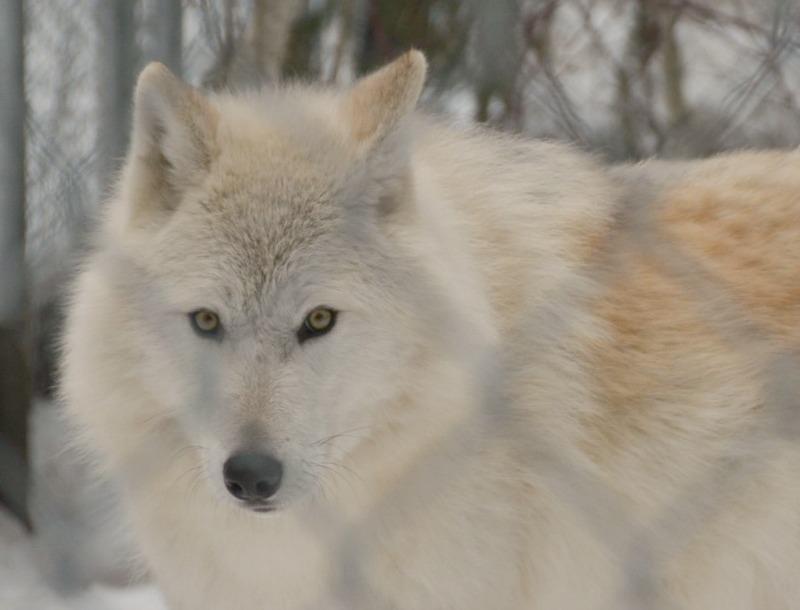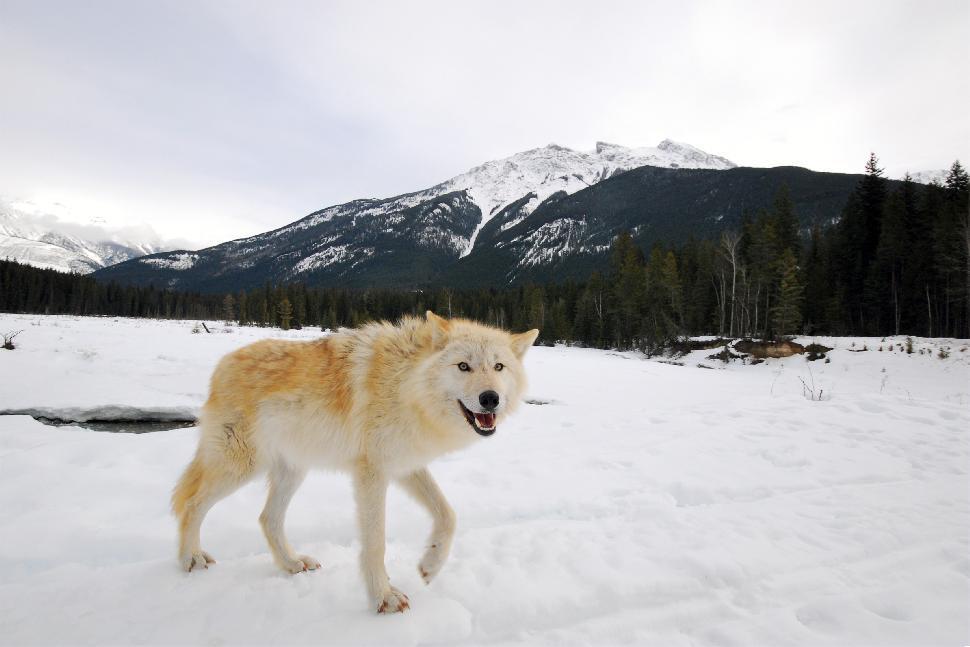The first image is the image on the left, the second image is the image on the right. Considering the images on both sides, is "At least one of the wild dogs is laying down and none are in snow." valid? Answer yes or no. No. 